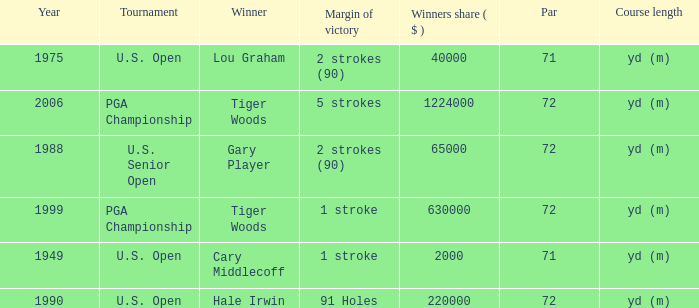When hale irwin is the winner what is the margin of victory? 91 Holes. 